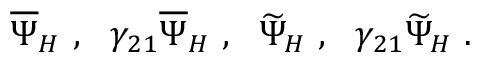<formula> <loc_0><loc_0><loc_500><loc_500>\overline { \Psi } _ { H } , \gamma _ { 2 1 } \overline { \Psi } _ { H } , \widetilde { \Psi } _ { H } , \gamma _ { 2 1 } \widetilde { \Psi } _ { H } .</formula> 